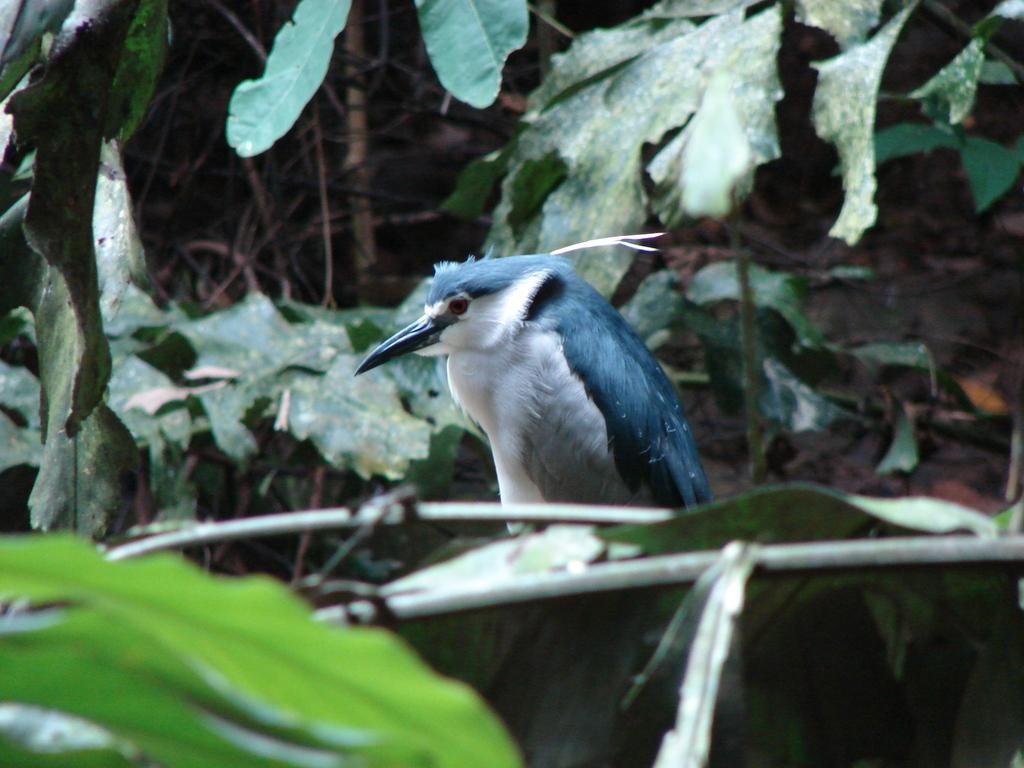Please provide a concise description of this image. We can see a bird and we can see stems and green leaves. 